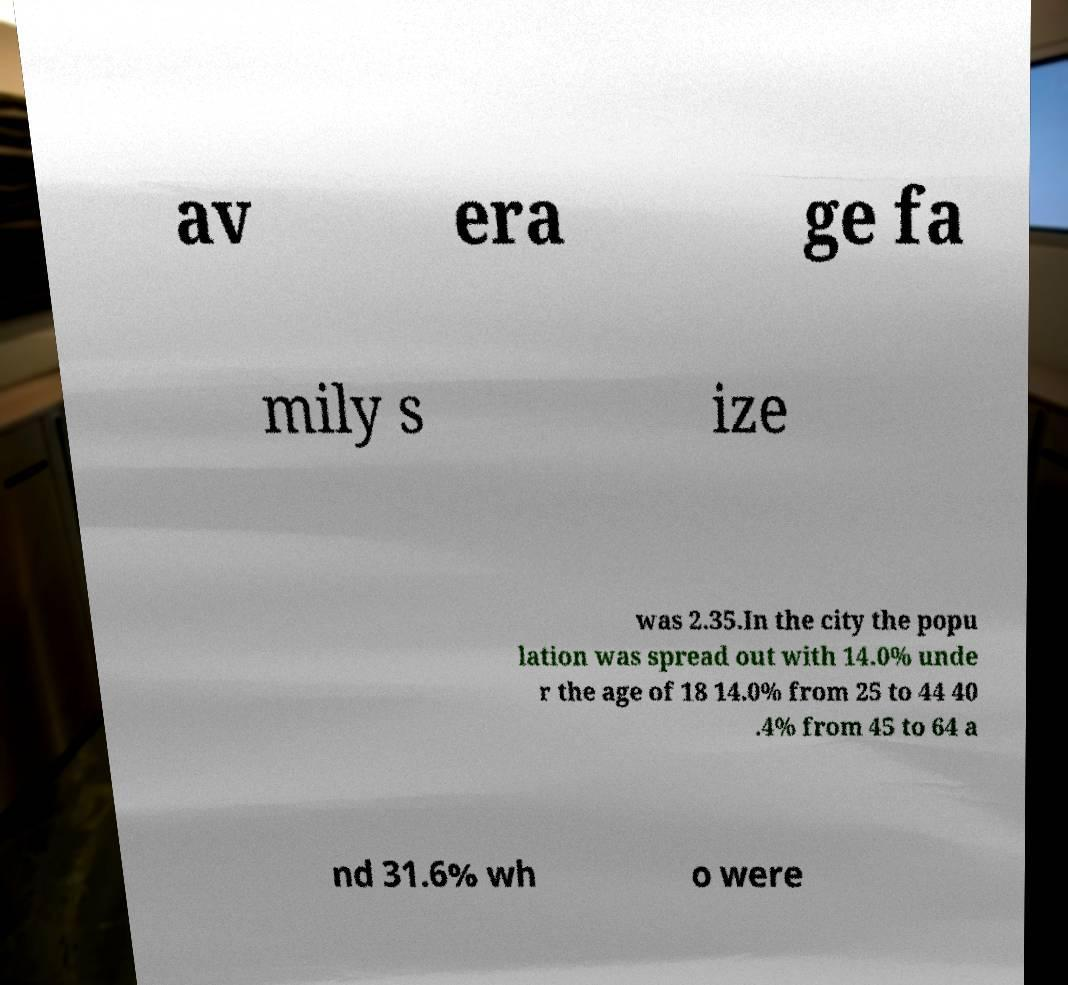Could you extract and type out the text from this image? av era ge fa mily s ize was 2.35.In the city the popu lation was spread out with 14.0% unde r the age of 18 14.0% from 25 to 44 40 .4% from 45 to 64 a nd 31.6% wh o were 